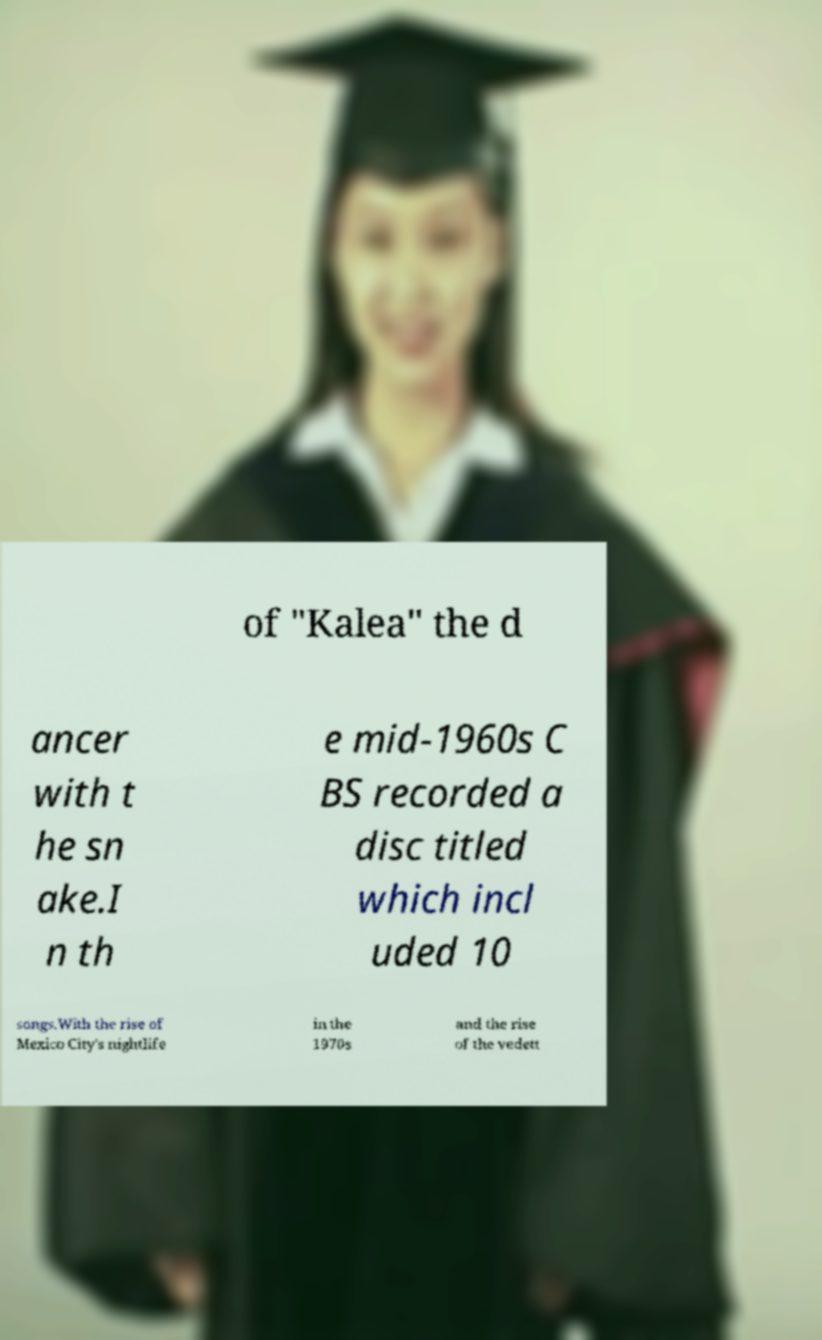Can you read and provide the text displayed in the image?This photo seems to have some interesting text. Can you extract and type it out for me? of "Kalea" the d ancer with t he sn ake.I n th e mid-1960s C BS recorded a disc titled which incl uded 10 songs.With the rise of Mexico City's nightlife in the 1970s and the rise of the vedett 